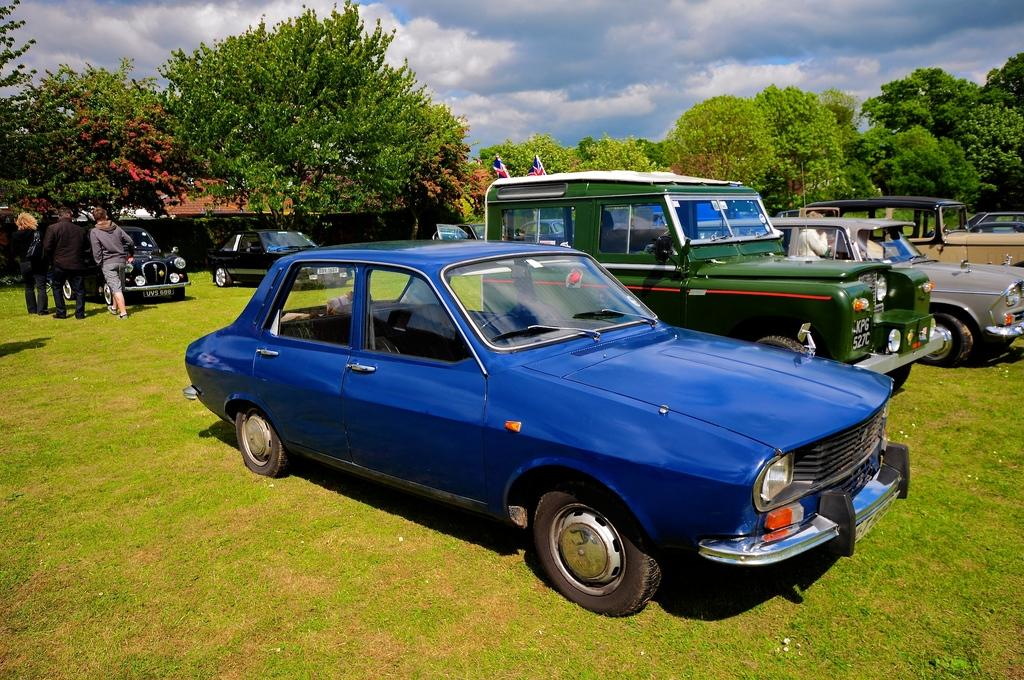What can be seen in the foreground of the image? In the foreground, there are fleets of cars on grass, flag poles, and four persons. Can you describe the people in the foreground? There are four persons in the foreground, but their specific characteristics are not mentioned in the facts. What is visible in the background of the image? In the background, there is a fence, trees, and the sky. What is the possible location of the image? The image may have been taken in a park, based on the presence of grass and trees. Reasoning: To produce the conversation, we first identify the main subjects and objects in the image based on the provided facts. We then formulate questions that focus on the location and characteristics of these subjects and objects, ensuring that each question can be answered definitively with the information given. We avoid yes/no questions and ensure that the language is simple and clear. Absurd Question/Answer: How many pieces of meat are on the flag poles in the image? There is no mention of meat in the image, and flag poles are not associated with meat. Can you tell me the color of the ladybug on the fence in the background? There is no ladybug mentioned in the image, so we cannot determine its color. What is the name of the daughter of one of the persons in the foreground? There is no mention of a daughter or any specific person's name in the image, so we cannot determine the name of a daughter. 